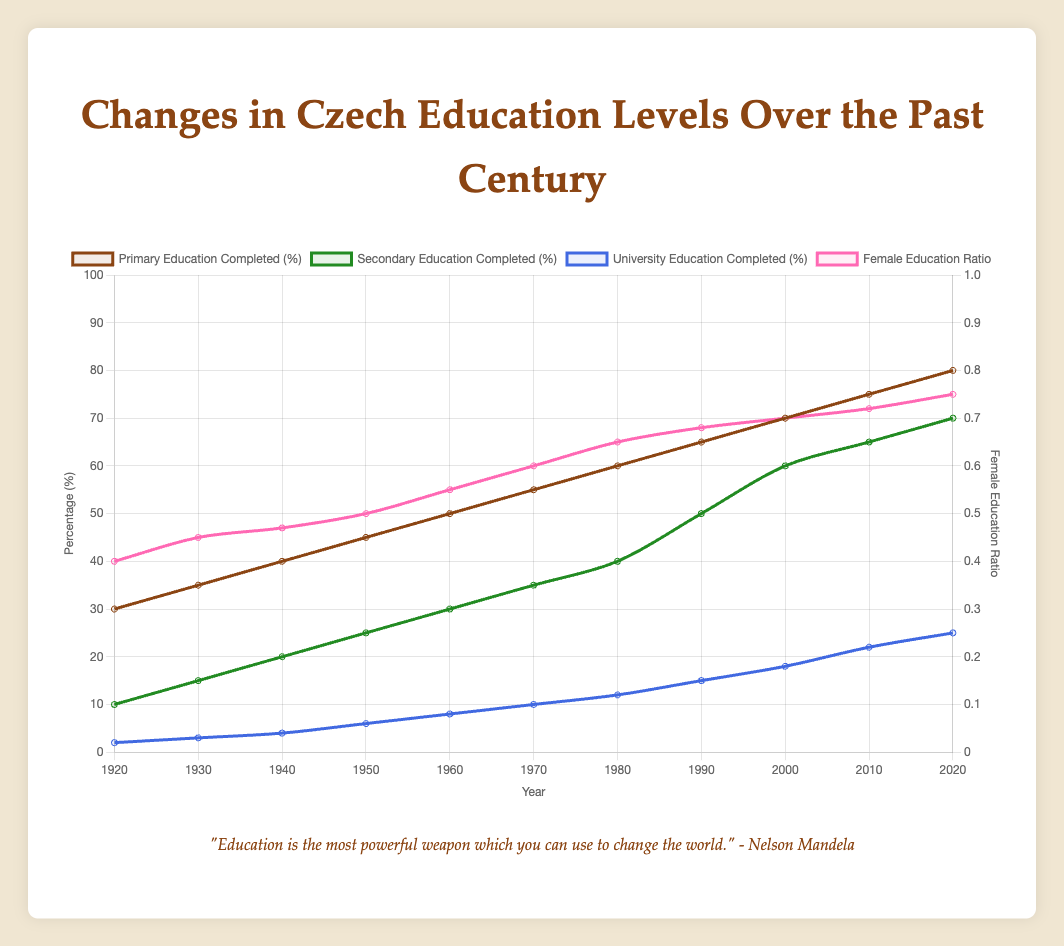What significant change occurred around 1948? According to the annotations, the Communist regime started in 1948, which led to substantial educational restructuring in Czechoslovakia.
Answer: Communist regime started, substantial educational restructuring Compare the trends of primary and secondary education completion rates from 1920 to 2020. Both primary and secondary education completion rates show an increasing trend over the years. Primary education starts higher and remains consistently above secondary education, but both show steady growth.
Answer: Both increased, but primary education was higher throughout How does the university education completion rate change from 1920 to 2000? The university education completion rate increased from 2% in 1920 to 18% in 2000, showing a gradual rise over the decades.
Answer: Increased from 2% to 18% In which year does the female education ratio first reach 50%? The female education ratio reaches 50% in 1950, as shown by the plotted line.
Answer: 1950 Which educational level had the most substantial increase between 1989 and 2004? University education completion shows a substantial increase from 12% in 1989 to 18% in 2000, as per the annotations marking Velvet Revolution (1989) and EU membership (2004).
Answer: University education completion What is the percentage difference in primary education completion between 1920 and 2020? The primary education completion in 1920 was 30%, and in 2020 it is 80%. The difference is 80% - 30% = 50%.
Answer: 50% Which educational level saw the smallest increase from 1920 to 2020? University education completion increased from 2% to 25%, which is an increase of 23%, the smallest relative change compared to primary and secondary education.
Answer: University education completion In what year did secondary education completion reach 50%? Secondary education completion reached 50% in 1990, indicated by the respective line on the chart.
Answer: 1990 What historical event corresponds with a notable increase in female education ratio? The Velvet Revolution in 1989 corresponds with a notable increase in the female education ratio, which significantly rose in the following years.
Answer: Velvet Revolution, 1989 What is the average increase in university education completion per decade from 1920 to 2020? The total increase from 2% in 1920 to 25% in 2020 is 25% - 2% = 23%. There are approximately 10 decades in this period. The average increase per decade is 23% / 10 = 2.3%.
Answer: 2.3% 